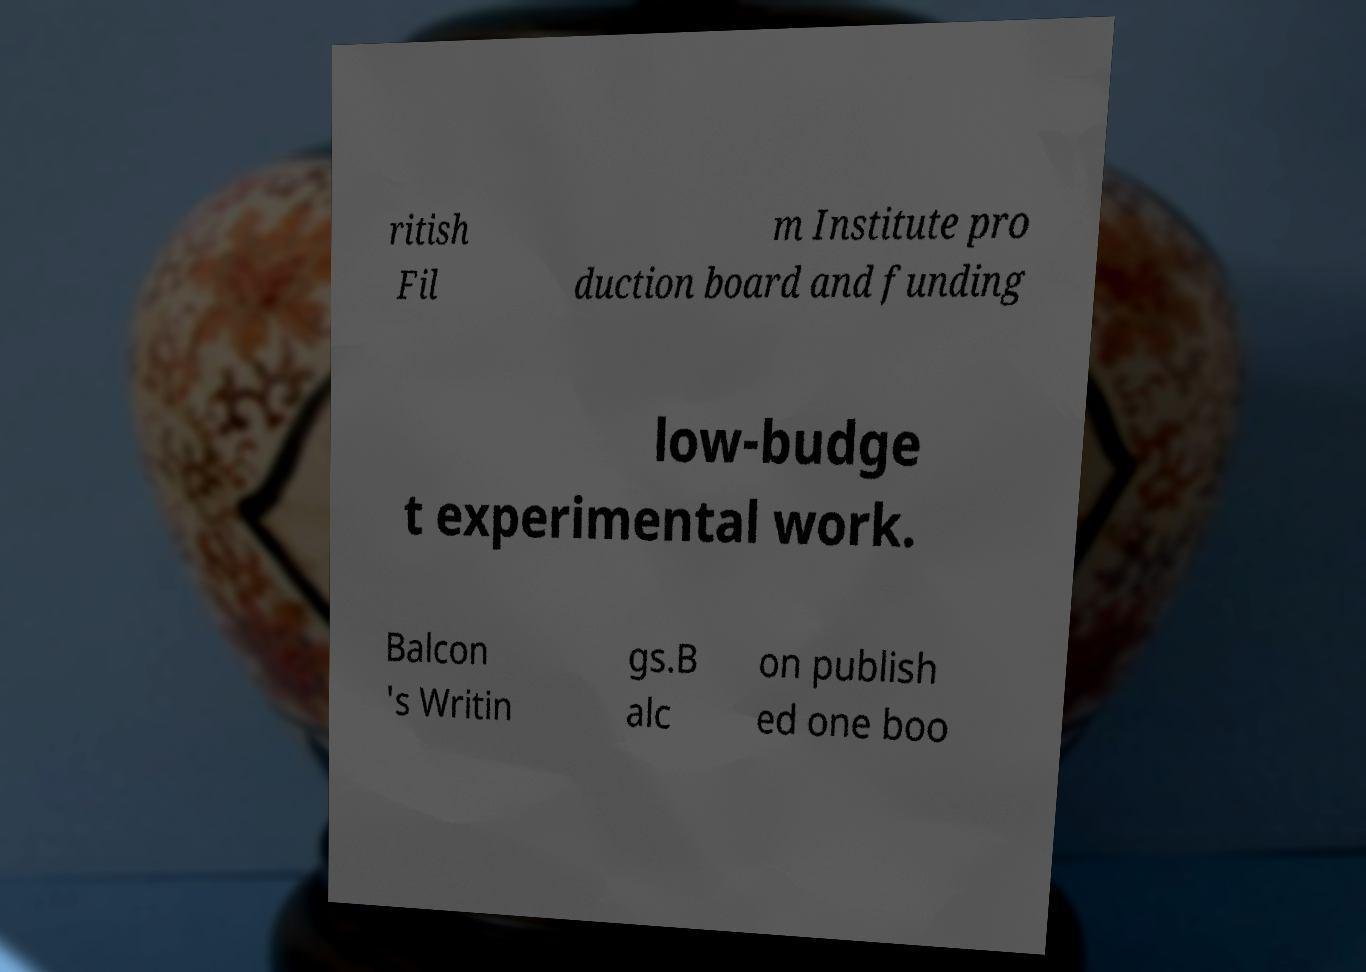Can you read and provide the text displayed in the image?This photo seems to have some interesting text. Can you extract and type it out for me? ritish Fil m Institute pro duction board and funding low-budge t experimental work. Balcon 's Writin gs.B alc on publish ed one boo 